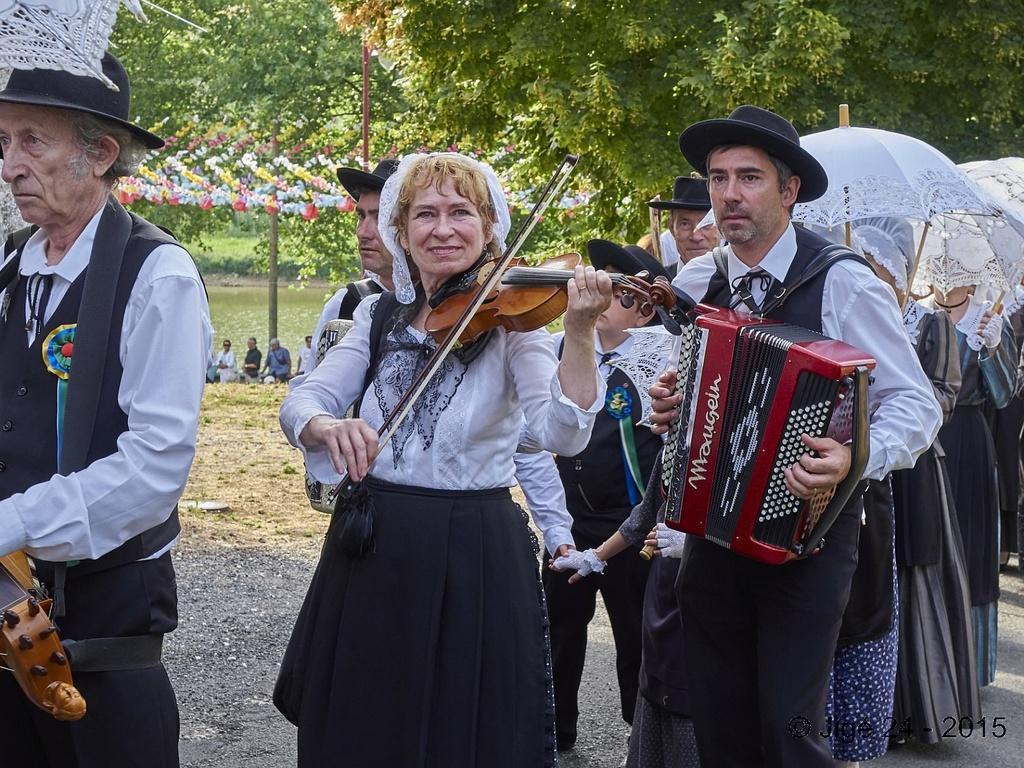Describe this image in one or two sentences. Here I can see few people are playing some musical instruments and standing on the road. On the right side there are few people holding umbrellas in their hands. In the background there is a lake and few people are standing. At the top of the image I can see the trees. 